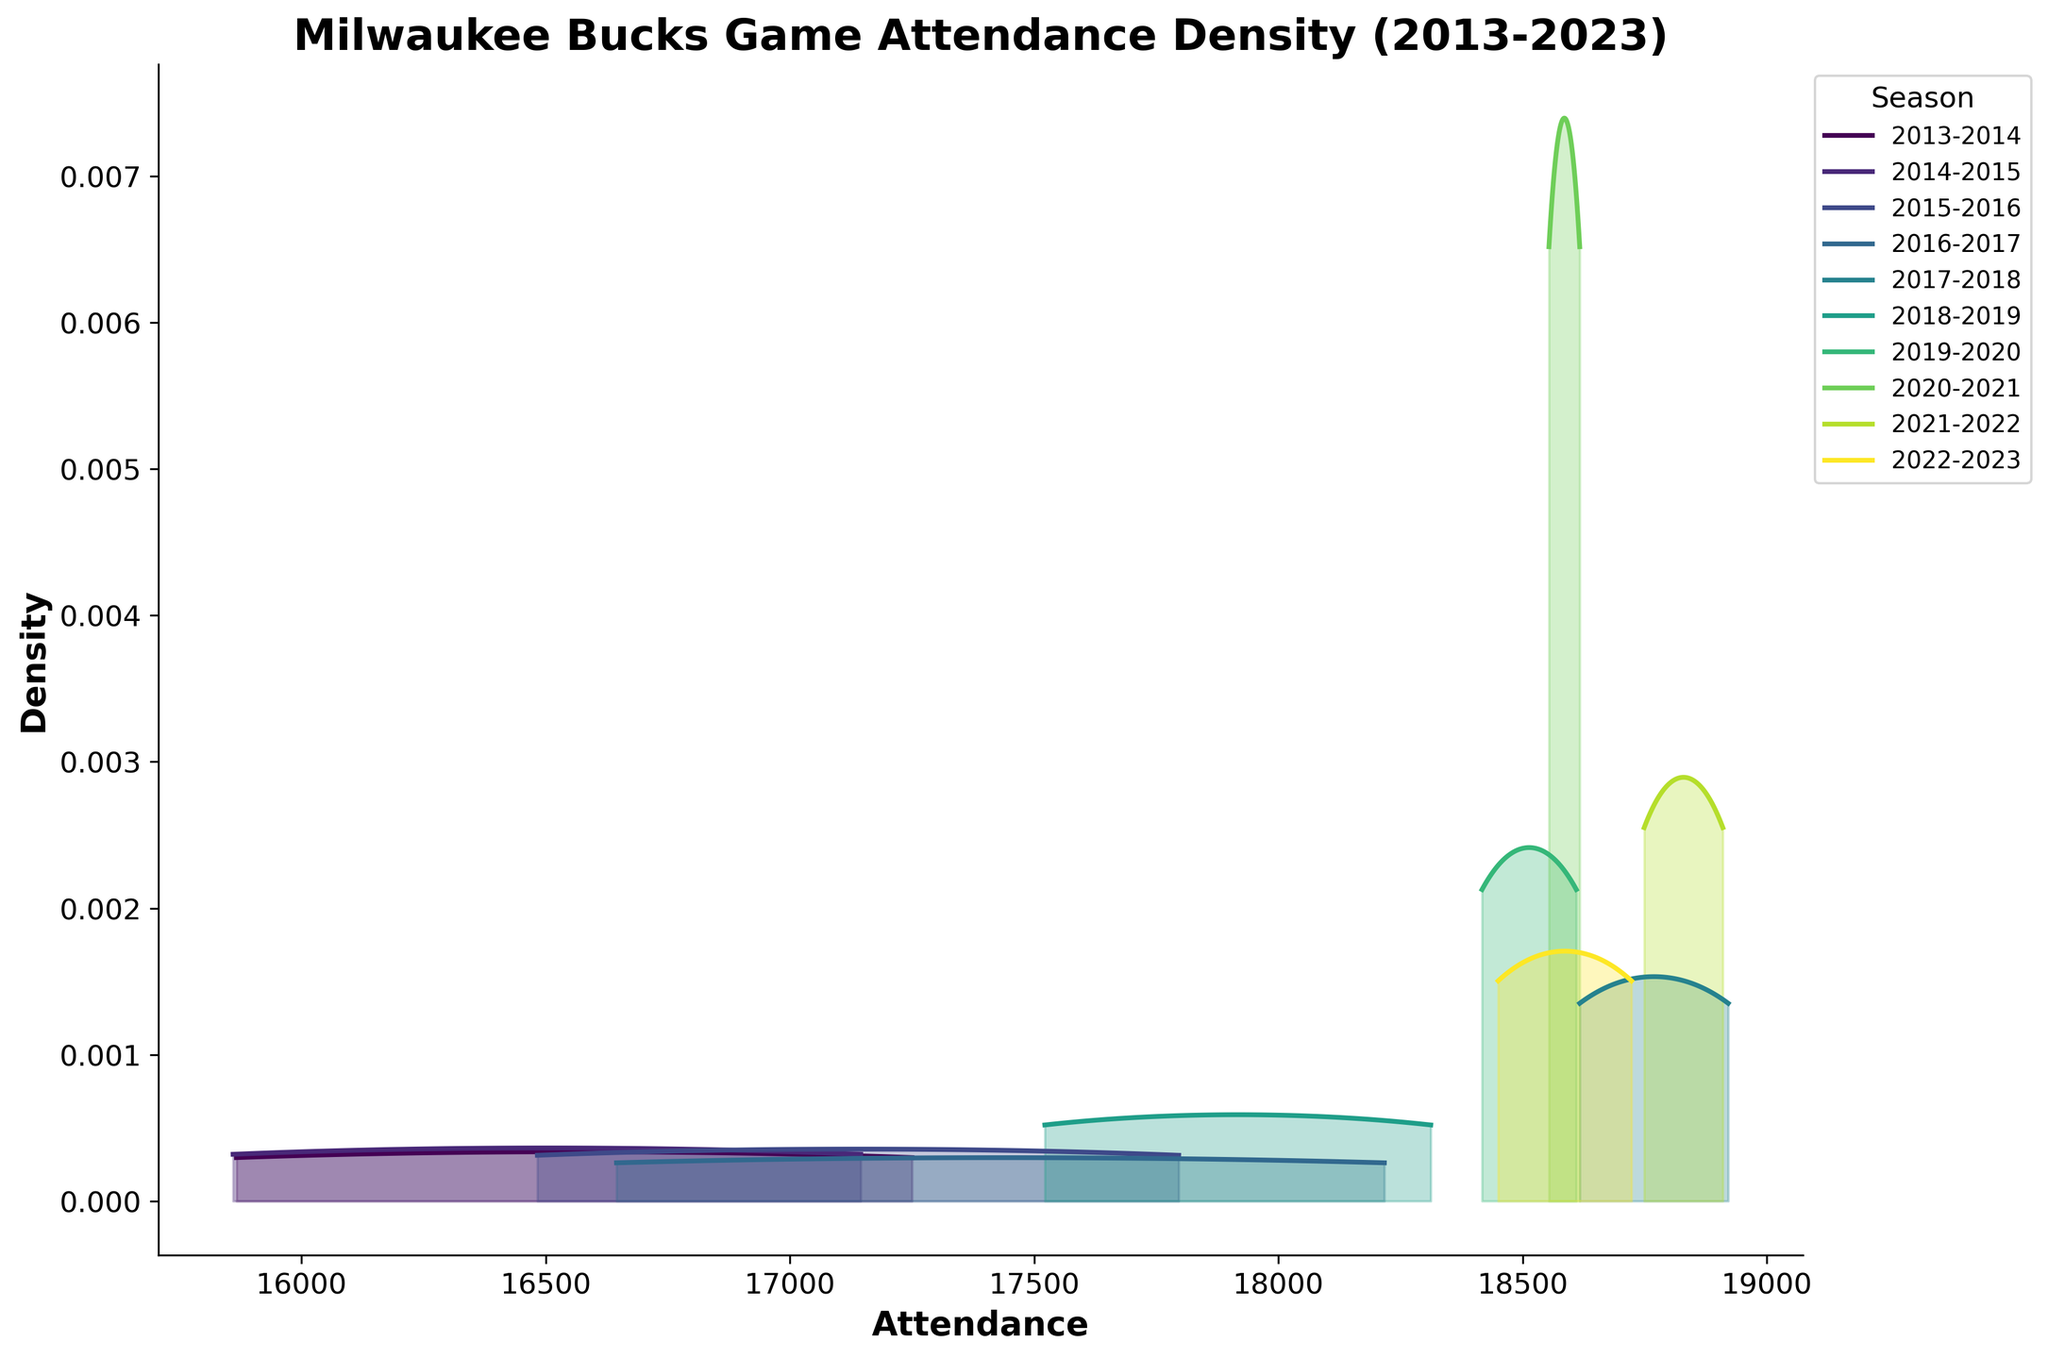What is the title of the subplot? The title is located at the top of the subplot. It describes the theme or focus of the visualization. In this case, it should indicate the topic of attendance trends.
Answer: Milwaukee Bucks Game Attendance Density (2013-2023) How many seasons are represented in the subplot? Each season is represented by a different color and noted in the legend on the right side of the plot. By counting the unique entries in the legend, we can determine the number of seasons.
Answer: 10 Which season shows the highest peak in attendance density? Identify the highest peak or peak density value among the different curves in the plot. The highest peak corresponds to the curve with the maximum density value.
Answer: 2019-2020 What is the range of attendance values shown on the x-axis? The x-axis represents attendance values. By examining the starting and ending points of the x-axis, we can determine the range of these values.
Answer: Approximately 15000 to 19000 Which season has the widest distribution of attendance values? The width of the attendance distribution can be determined by the spread of the curve along the x-axis. The season with the most stretched-out curve has the widest distribution.
Answer: 2015-2016 Between which attendance values does the season 2017-2018 have its highest density? Identify the highest density point for the season 2017-2018 by observing its curve and then note down the x-axis values corresponding to that peak.
Answer: Approximately 18500 Which season has the smallest peak in attendance density? Compare the heights of the peaks for all seasons. The season with the smallest peak represents the lowest maximum density value.
Answer: 2013-2014 How do the attendance density trends differ for the seasons 2020-2021 and 2021-2022? Compare the curves for these two seasons in terms of their shape, peak locations, and spread along the x-axis to understand how the attendance densities differ.
Answer: 2020-2021 is more concentrated around higher attendance values, while 2021-2022 shows a more even distribution What general trend can be observed in attendance density from the season 2013-2014 to the season 2019-2020? By analyzing the peaks and spreads of the attendance curves over these years, we can determine if there is a general increase or decrease in attendance density.
Answer: There is a general increase in attendance density over the years Which key match had the highest attendance, and how does it reflect in the density plot? Identify the key match with the highest attendance from the data and locate where this high attendance point might influence the density curve for the respective season.
Answer: Milwaukee Bucks vs Philadelphia 76ers (2017-2018) with 18921; this is reflected by a sharper peak around 18900 in that season's density plot 